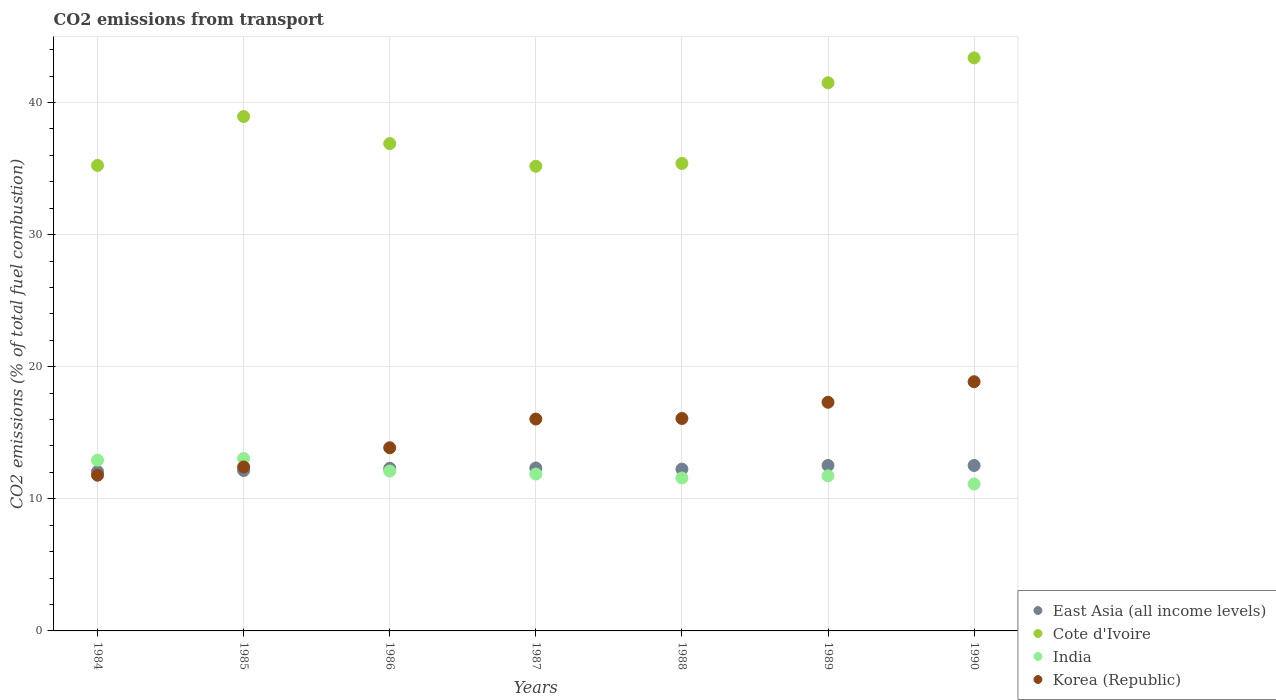How many different coloured dotlines are there?
Your response must be concise. 4. Is the number of dotlines equal to the number of legend labels?
Your answer should be very brief. Yes. What is the total CO2 emitted in Cote d'Ivoire in 1986?
Keep it short and to the point. 36.89. Across all years, what is the maximum total CO2 emitted in Korea (Republic)?
Keep it short and to the point. 18.87. Across all years, what is the minimum total CO2 emitted in India?
Your response must be concise. 11.12. In which year was the total CO2 emitted in East Asia (all income levels) maximum?
Your answer should be very brief. 1989. What is the total total CO2 emitted in India in the graph?
Ensure brevity in your answer.  84.4. What is the difference between the total CO2 emitted in Korea (Republic) in 1984 and that in 1985?
Give a very brief answer. -0.62. What is the difference between the total CO2 emitted in East Asia (all income levels) in 1984 and the total CO2 emitted in India in 1986?
Your answer should be compact. -0.03. What is the average total CO2 emitted in East Asia (all income levels) per year?
Your response must be concise. 12.31. In the year 1988, what is the difference between the total CO2 emitted in Cote d'Ivoire and total CO2 emitted in India?
Make the answer very short. 23.81. In how many years, is the total CO2 emitted in East Asia (all income levels) greater than 2?
Your response must be concise. 7. What is the ratio of the total CO2 emitted in Cote d'Ivoire in 1984 to that in 1985?
Provide a short and direct response. 0.9. Is the difference between the total CO2 emitted in Cote d'Ivoire in 1984 and 1985 greater than the difference between the total CO2 emitted in India in 1984 and 1985?
Your answer should be compact. No. What is the difference between the highest and the second highest total CO2 emitted in India?
Make the answer very short. 0.12. What is the difference between the highest and the lowest total CO2 emitted in Korea (Republic)?
Provide a succinct answer. 7.08. Is the sum of the total CO2 emitted in Cote d'Ivoire in 1984 and 1989 greater than the maximum total CO2 emitted in East Asia (all income levels) across all years?
Provide a short and direct response. Yes. Does the total CO2 emitted in Cote d'Ivoire monotonically increase over the years?
Keep it short and to the point. No. Is the total CO2 emitted in Cote d'Ivoire strictly greater than the total CO2 emitted in Korea (Republic) over the years?
Make the answer very short. Yes. Is the total CO2 emitted in Cote d'Ivoire strictly less than the total CO2 emitted in India over the years?
Your answer should be compact. No. How many dotlines are there?
Your answer should be very brief. 4. Are the values on the major ticks of Y-axis written in scientific E-notation?
Provide a succinct answer. No. Does the graph contain any zero values?
Your response must be concise. No. Does the graph contain grids?
Keep it short and to the point. Yes. Where does the legend appear in the graph?
Your answer should be very brief. Bottom right. How many legend labels are there?
Ensure brevity in your answer.  4. What is the title of the graph?
Provide a succinct answer. CO2 emissions from transport. What is the label or title of the Y-axis?
Offer a terse response. CO2 emissions (% of total fuel combustion). What is the CO2 emissions (% of total fuel combustion) of East Asia (all income levels) in 1984?
Offer a terse response. 12.07. What is the CO2 emissions (% of total fuel combustion) of Cote d'Ivoire in 1984?
Your answer should be very brief. 35.24. What is the CO2 emissions (% of total fuel combustion) of India in 1984?
Your answer should be compact. 12.93. What is the CO2 emissions (% of total fuel combustion) in Korea (Republic) in 1984?
Provide a short and direct response. 11.79. What is the CO2 emissions (% of total fuel combustion) in East Asia (all income levels) in 1985?
Your answer should be compact. 12.14. What is the CO2 emissions (% of total fuel combustion) in Cote d'Ivoire in 1985?
Ensure brevity in your answer.  38.94. What is the CO2 emissions (% of total fuel combustion) of India in 1985?
Offer a very short reply. 13.05. What is the CO2 emissions (% of total fuel combustion) of Korea (Republic) in 1985?
Make the answer very short. 12.41. What is the CO2 emissions (% of total fuel combustion) in East Asia (all income levels) in 1986?
Offer a very short reply. 12.31. What is the CO2 emissions (% of total fuel combustion) of Cote d'Ivoire in 1986?
Provide a succinct answer. 36.89. What is the CO2 emissions (% of total fuel combustion) in India in 1986?
Provide a short and direct response. 12.1. What is the CO2 emissions (% of total fuel combustion) in Korea (Republic) in 1986?
Give a very brief answer. 13.87. What is the CO2 emissions (% of total fuel combustion) of East Asia (all income levels) in 1987?
Provide a short and direct response. 12.34. What is the CO2 emissions (% of total fuel combustion) of Cote d'Ivoire in 1987?
Your answer should be very brief. 35.18. What is the CO2 emissions (% of total fuel combustion) in India in 1987?
Provide a succinct answer. 11.88. What is the CO2 emissions (% of total fuel combustion) in Korea (Republic) in 1987?
Your answer should be very brief. 16.04. What is the CO2 emissions (% of total fuel combustion) of East Asia (all income levels) in 1988?
Provide a short and direct response. 12.25. What is the CO2 emissions (% of total fuel combustion) in Cote d'Ivoire in 1988?
Offer a terse response. 35.39. What is the CO2 emissions (% of total fuel combustion) of India in 1988?
Make the answer very short. 11.58. What is the CO2 emissions (% of total fuel combustion) in Korea (Republic) in 1988?
Keep it short and to the point. 16.08. What is the CO2 emissions (% of total fuel combustion) of East Asia (all income levels) in 1989?
Offer a very short reply. 12.53. What is the CO2 emissions (% of total fuel combustion) of Cote d'Ivoire in 1989?
Keep it short and to the point. 41.5. What is the CO2 emissions (% of total fuel combustion) of India in 1989?
Your answer should be very brief. 11.74. What is the CO2 emissions (% of total fuel combustion) in Korea (Republic) in 1989?
Provide a short and direct response. 17.31. What is the CO2 emissions (% of total fuel combustion) in East Asia (all income levels) in 1990?
Your answer should be compact. 12.53. What is the CO2 emissions (% of total fuel combustion) in Cote d'Ivoire in 1990?
Your answer should be compact. 43.38. What is the CO2 emissions (% of total fuel combustion) of India in 1990?
Offer a terse response. 11.12. What is the CO2 emissions (% of total fuel combustion) in Korea (Republic) in 1990?
Your response must be concise. 18.87. Across all years, what is the maximum CO2 emissions (% of total fuel combustion) in East Asia (all income levels)?
Ensure brevity in your answer.  12.53. Across all years, what is the maximum CO2 emissions (% of total fuel combustion) in Cote d'Ivoire?
Offer a very short reply. 43.38. Across all years, what is the maximum CO2 emissions (% of total fuel combustion) in India?
Your response must be concise. 13.05. Across all years, what is the maximum CO2 emissions (% of total fuel combustion) in Korea (Republic)?
Offer a very short reply. 18.87. Across all years, what is the minimum CO2 emissions (% of total fuel combustion) in East Asia (all income levels)?
Your answer should be very brief. 12.07. Across all years, what is the minimum CO2 emissions (% of total fuel combustion) of Cote d'Ivoire?
Make the answer very short. 35.18. Across all years, what is the minimum CO2 emissions (% of total fuel combustion) in India?
Your response must be concise. 11.12. Across all years, what is the minimum CO2 emissions (% of total fuel combustion) in Korea (Republic)?
Your response must be concise. 11.79. What is the total CO2 emissions (% of total fuel combustion) in East Asia (all income levels) in the graph?
Your answer should be very brief. 86.16. What is the total CO2 emissions (% of total fuel combustion) in Cote d'Ivoire in the graph?
Provide a succinct answer. 266.53. What is the total CO2 emissions (% of total fuel combustion) in India in the graph?
Provide a short and direct response. 84.4. What is the total CO2 emissions (% of total fuel combustion) in Korea (Republic) in the graph?
Provide a succinct answer. 106.37. What is the difference between the CO2 emissions (% of total fuel combustion) in East Asia (all income levels) in 1984 and that in 1985?
Provide a succinct answer. -0.07. What is the difference between the CO2 emissions (% of total fuel combustion) of Cote d'Ivoire in 1984 and that in 1985?
Your answer should be very brief. -3.7. What is the difference between the CO2 emissions (% of total fuel combustion) of India in 1984 and that in 1985?
Your answer should be very brief. -0.12. What is the difference between the CO2 emissions (% of total fuel combustion) of Korea (Republic) in 1984 and that in 1985?
Your answer should be very brief. -0.62. What is the difference between the CO2 emissions (% of total fuel combustion) of East Asia (all income levels) in 1984 and that in 1986?
Your answer should be very brief. -0.24. What is the difference between the CO2 emissions (% of total fuel combustion) of Cote d'Ivoire in 1984 and that in 1986?
Your answer should be compact. -1.65. What is the difference between the CO2 emissions (% of total fuel combustion) of India in 1984 and that in 1986?
Ensure brevity in your answer.  0.83. What is the difference between the CO2 emissions (% of total fuel combustion) in Korea (Republic) in 1984 and that in 1986?
Offer a terse response. -2.08. What is the difference between the CO2 emissions (% of total fuel combustion) of East Asia (all income levels) in 1984 and that in 1987?
Give a very brief answer. -0.27. What is the difference between the CO2 emissions (% of total fuel combustion) of Cote d'Ivoire in 1984 and that in 1987?
Give a very brief answer. 0.06. What is the difference between the CO2 emissions (% of total fuel combustion) of India in 1984 and that in 1987?
Keep it short and to the point. 1.05. What is the difference between the CO2 emissions (% of total fuel combustion) of Korea (Republic) in 1984 and that in 1987?
Make the answer very short. -4.25. What is the difference between the CO2 emissions (% of total fuel combustion) of East Asia (all income levels) in 1984 and that in 1988?
Provide a succinct answer. -0.18. What is the difference between the CO2 emissions (% of total fuel combustion) in Cote d'Ivoire in 1984 and that in 1988?
Offer a terse response. -0.15. What is the difference between the CO2 emissions (% of total fuel combustion) in India in 1984 and that in 1988?
Provide a short and direct response. 1.35. What is the difference between the CO2 emissions (% of total fuel combustion) of Korea (Republic) in 1984 and that in 1988?
Offer a terse response. -4.29. What is the difference between the CO2 emissions (% of total fuel combustion) of East Asia (all income levels) in 1984 and that in 1989?
Give a very brief answer. -0.46. What is the difference between the CO2 emissions (% of total fuel combustion) in Cote d'Ivoire in 1984 and that in 1989?
Give a very brief answer. -6.26. What is the difference between the CO2 emissions (% of total fuel combustion) of India in 1984 and that in 1989?
Your answer should be compact. 1.19. What is the difference between the CO2 emissions (% of total fuel combustion) in Korea (Republic) in 1984 and that in 1989?
Provide a succinct answer. -5.52. What is the difference between the CO2 emissions (% of total fuel combustion) in East Asia (all income levels) in 1984 and that in 1990?
Offer a terse response. -0.46. What is the difference between the CO2 emissions (% of total fuel combustion) of Cote d'Ivoire in 1984 and that in 1990?
Ensure brevity in your answer.  -8.14. What is the difference between the CO2 emissions (% of total fuel combustion) in India in 1984 and that in 1990?
Your answer should be compact. 1.81. What is the difference between the CO2 emissions (% of total fuel combustion) in Korea (Republic) in 1984 and that in 1990?
Your answer should be compact. -7.08. What is the difference between the CO2 emissions (% of total fuel combustion) in East Asia (all income levels) in 1985 and that in 1986?
Offer a terse response. -0.17. What is the difference between the CO2 emissions (% of total fuel combustion) of Cote d'Ivoire in 1985 and that in 1986?
Provide a short and direct response. 2.05. What is the difference between the CO2 emissions (% of total fuel combustion) in India in 1985 and that in 1986?
Provide a succinct answer. 0.95. What is the difference between the CO2 emissions (% of total fuel combustion) of Korea (Republic) in 1985 and that in 1986?
Your answer should be compact. -1.46. What is the difference between the CO2 emissions (% of total fuel combustion) of East Asia (all income levels) in 1985 and that in 1987?
Your answer should be compact. -0.19. What is the difference between the CO2 emissions (% of total fuel combustion) of Cote d'Ivoire in 1985 and that in 1987?
Make the answer very short. 3.76. What is the difference between the CO2 emissions (% of total fuel combustion) in India in 1985 and that in 1987?
Provide a succinct answer. 1.18. What is the difference between the CO2 emissions (% of total fuel combustion) in Korea (Republic) in 1985 and that in 1987?
Ensure brevity in your answer.  -3.63. What is the difference between the CO2 emissions (% of total fuel combustion) of East Asia (all income levels) in 1985 and that in 1988?
Your answer should be compact. -0.11. What is the difference between the CO2 emissions (% of total fuel combustion) of Cote d'Ivoire in 1985 and that in 1988?
Make the answer very short. 3.55. What is the difference between the CO2 emissions (% of total fuel combustion) of India in 1985 and that in 1988?
Keep it short and to the point. 1.48. What is the difference between the CO2 emissions (% of total fuel combustion) in Korea (Republic) in 1985 and that in 1988?
Keep it short and to the point. -3.67. What is the difference between the CO2 emissions (% of total fuel combustion) of East Asia (all income levels) in 1985 and that in 1989?
Provide a succinct answer. -0.38. What is the difference between the CO2 emissions (% of total fuel combustion) in Cote d'Ivoire in 1985 and that in 1989?
Keep it short and to the point. -2.55. What is the difference between the CO2 emissions (% of total fuel combustion) in India in 1985 and that in 1989?
Your answer should be compact. 1.31. What is the difference between the CO2 emissions (% of total fuel combustion) in East Asia (all income levels) in 1985 and that in 1990?
Ensure brevity in your answer.  -0.38. What is the difference between the CO2 emissions (% of total fuel combustion) of Cote d'Ivoire in 1985 and that in 1990?
Make the answer very short. -4.44. What is the difference between the CO2 emissions (% of total fuel combustion) of India in 1985 and that in 1990?
Give a very brief answer. 1.93. What is the difference between the CO2 emissions (% of total fuel combustion) in Korea (Republic) in 1985 and that in 1990?
Ensure brevity in your answer.  -6.46. What is the difference between the CO2 emissions (% of total fuel combustion) in East Asia (all income levels) in 1986 and that in 1987?
Provide a short and direct response. -0.02. What is the difference between the CO2 emissions (% of total fuel combustion) in Cote d'Ivoire in 1986 and that in 1987?
Provide a short and direct response. 1.71. What is the difference between the CO2 emissions (% of total fuel combustion) of India in 1986 and that in 1987?
Provide a succinct answer. 0.23. What is the difference between the CO2 emissions (% of total fuel combustion) of Korea (Republic) in 1986 and that in 1987?
Provide a succinct answer. -2.17. What is the difference between the CO2 emissions (% of total fuel combustion) of East Asia (all income levels) in 1986 and that in 1988?
Offer a very short reply. 0.06. What is the difference between the CO2 emissions (% of total fuel combustion) of Cote d'Ivoire in 1986 and that in 1988?
Offer a very short reply. 1.5. What is the difference between the CO2 emissions (% of total fuel combustion) of India in 1986 and that in 1988?
Offer a very short reply. 0.53. What is the difference between the CO2 emissions (% of total fuel combustion) in Korea (Republic) in 1986 and that in 1988?
Provide a short and direct response. -2.22. What is the difference between the CO2 emissions (% of total fuel combustion) of East Asia (all income levels) in 1986 and that in 1989?
Offer a very short reply. -0.21. What is the difference between the CO2 emissions (% of total fuel combustion) of Cote d'Ivoire in 1986 and that in 1989?
Offer a terse response. -4.6. What is the difference between the CO2 emissions (% of total fuel combustion) in India in 1986 and that in 1989?
Your response must be concise. 0.36. What is the difference between the CO2 emissions (% of total fuel combustion) in Korea (Republic) in 1986 and that in 1989?
Your response must be concise. -3.44. What is the difference between the CO2 emissions (% of total fuel combustion) of East Asia (all income levels) in 1986 and that in 1990?
Offer a very short reply. -0.21. What is the difference between the CO2 emissions (% of total fuel combustion) in Cote d'Ivoire in 1986 and that in 1990?
Keep it short and to the point. -6.49. What is the difference between the CO2 emissions (% of total fuel combustion) of India in 1986 and that in 1990?
Your answer should be very brief. 0.98. What is the difference between the CO2 emissions (% of total fuel combustion) of Korea (Republic) in 1986 and that in 1990?
Provide a succinct answer. -5. What is the difference between the CO2 emissions (% of total fuel combustion) in East Asia (all income levels) in 1987 and that in 1988?
Make the answer very short. 0.09. What is the difference between the CO2 emissions (% of total fuel combustion) in Cote d'Ivoire in 1987 and that in 1988?
Give a very brief answer. -0.21. What is the difference between the CO2 emissions (% of total fuel combustion) of India in 1987 and that in 1988?
Provide a succinct answer. 0.3. What is the difference between the CO2 emissions (% of total fuel combustion) of Korea (Republic) in 1987 and that in 1988?
Your response must be concise. -0.04. What is the difference between the CO2 emissions (% of total fuel combustion) in East Asia (all income levels) in 1987 and that in 1989?
Your answer should be compact. -0.19. What is the difference between the CO2 emissions (% of total fuel combustion) in Cote d'Ivoire in 1987 and that in 1989?
Keep it short and to the point. -6.32. What is the difference between the CO2 emissions (% of total fuel combustion) in India in 1987 and that in 1989?
Offer a terse response. 0.14. What is the difference between the CO2 emissions (% of total fuel combustion) in Korea (Republic) in 1987 and that in 1989?
Provide a succinct answer. -1.27. What is the difference between the CO2 emissions (% of total fuel combustion) of East Asia (all income levels) in 1987 and that in 1990?
Your answer should be compact. -0.19. What is the difference between the CO2 emissions (% of total fuel combustion) in Cote d'Ivoire in 1987 and that in 1990?
Provide a succinct answer. -8.2. What is the difference between the CO2 emissions (% of total fuel combustion) in India in 1987 and that in 1990?
Make the answer very short. 0.76. What is the difference between the CO2 emissions (% of total fuel combustion) in Korea (Republic) in 1987 and that in 1990?
Your answer should be compact. -2.83. What is the difference between the CO2 emissions (% of total fuel combustion) of East Asia (all income levels) in 1988 and that in 1989?
Your answer should be very brief. -0.28. What is the difference between the CO2 emissions (% of total fuel combustion) in Cote d'Ivoire in 1988 and that in 1989?
Offer a terse response. -6.11. What is the difference between the CO2 emissions (% of total fuel combustion) of India in 1988 and that in 1989?
Keep it short and to the point. -0.16. What is the difference between the CO2 emissions (% of total fuel combustion) of Korea (Republic) in 1988 and that in 1989?
Your answer should be compact. -1.23. What is the difference between the CO2 emissions (% of total fuel combustion) in East Asia (all income levels) in 1988 and that in 1990?
Your response must be concise. -0.28. What is the difference between the CO2 emissions (% of total fuel combustion) in Cote d'Ivoire in 1988 and that in 1990?
Make the answer very short. -7.99. What is the difference between the CO2 emissions (% of total fuel combustion) of India in 1988 and that in 1990?
Your answer should be compact. 0.46. What is the difference between the CO2 emissions (% of total fuel combustion) in Korea (Republic) in 1988 and that in 1990?
Provide a short and direct response. -2.78. What is the difference between the CO2 emissions (% of total fuel combustion) in East Asia (all income levels) in 1989 and that in 1990?
Offer a terse response. 0. What is the difference between the CO2 emissions (% of total fuel combustion) of Cote d'Ivoire in 1989 and that in 1990?
Ensure brevity in your answer.  -1.89. What is the difference between the CO2 emissions (% of total fuel combustion) in India in 1989 and that in 1990?
Provide a short and direct response. 0.62. What is the difference between the CO2 emissions (% of total fuel combustion) in Korea (Republic) in 1989 and that in 1990?
Provide a short and direct response. -1.56. What is the difference between the CO2 emissions (% of total fuel combustion) in East Asia (all income levels) in 1984 and the CO2 emissions (% of total fuel combustion) in Cote d'Ivoire in 1985?
Make the answer very short. -26.87. What is the difference between the CO2 emissions (% of total fuel combustion) in East Asia (all income levels) in 1984 and the CO2 emissions (% of total fuel combustion) in India in 1985?
Offer a terse response. -0.98. What is the difference between the CO2 emissions (% of total fuel combustion) in East Asia (all income levels) in 1984 and the CO2 emissions (% of total fuel combustion) in Korea (Republic) in 1985?
Ensure brevity in your answer.  -0.34. What is the difference between the CO2 emissions (% of total fuel combustion) in Cote d'Ivoire in 1984 and the CO2 emissions (% of total fuel combustion) in India in 1985?
Provide a succinct answer. 22.19. What is the difference between the CO2 emissions (% of total fuel combustion) in Cote d'Ivoire in 1984 and the CO2 emissions (% of total fuel combustion) in Korea (Republic) in 1985?
Give a very brief answer. 22.83. What is the difference between the CO2 emissions (% of total fuel combustion) in India in 1984 and the CO2 emissions (% of total fuel combustion) in Korea (Republic) in 1985?
Give a very brief answer. 0.52. What is the difference between the CO2 emissions (% of total fuel combustion) in East Asia (all income levels) in 1984 and the CO2 emissions (% of total fuel combustion) in Cote d'Ivoire in 1986?
Your response must be concise. -24.82. What is the difference between the CO2 emissions (% of total fuel combustion) of East Asia (all income levels) in 1984 and the CO2 emissions (% of total fuel combustion) of India in 1986?
Keep it short and to the point. -0.03. What is the difference between the CO2 emissions (% of total fuel combustion) of East Asia (all income levels) in 1984 and the CO2 emissions (% of total fuel combustion) of Korea (Republic) in 1986?
Give a very brief answer. -1.8. What is the difference between the CO2 emissions (% of total fuel combustion) of Cote d'Ivoire in 1984 and the CO2 emissions (% of total fuel combustion) of India in 1986?
Your answer should be very brief. 23.14. What is the difference between the CO2 emissions (% of total fuel combustion) in Cote d'Ivoire in 1984 and the CO2 emissions (% of total fuel combustion) in Korea (Republic) in 1986?
Offer a very short reply. 21.37. What is the difference between the CO2 emissions (% of total fuel combustion) in India in 1984 and the CO2 emissions (% of total fuel combustion) in Korea (Republic) in 1986?
Keep it short and to the point. -0.94. What is the difference between the CO2 emissions (% of total fuel combustion) in East Asia (all income levels) in 1984 and the CO2 emissions (% of total fuel combustion) in Cote d'Ivoire in 1987?
Offer a very short reply. -23.11. What is the difference between the CO2 emissions (% of total fuel combustion) of East Asia (all income levels) in 1984 and the CO2 emissions (% of total fuel combustion) of India in 1987?
Offer a terse response. 0.19. What is the difference between the CO2 emissions (% of total fuel combustion) in East Asia (all income levels) in 1984 and the CO2 emissions (% of total fuel combustion) in Korea (Republic) in 1987?
Your answer should be compact. -3.97. What is the difference between the CO2 emissions (% of total fuel combustion) in Cote d'Ivoire in 1984 and the CO2 emissions (% of total fuel combustion) in India in 1987?
Your answer should be very brief. 23.36. What is the difference between the CO2 emissions (% of total fuel combustion) in India in 1984 and the CO2 emissions (% of total fuel combustion) in Korea (Republic) in 1987?
Ensure brevity in your answer.  -3.11. What is the difference between the CO2 emissions (% of total fuel combustion) of East Asia (all income levels) in 1984 and the CO2 emissions (% of total fuel combustion) of Cote d'Ivoire in 1988?
Offer a very short reply. -23.32. What is the difference between the CO2 emissions (% of total fuel combustion) of East Asia (all income levels) in 1984 and the CO2 emissions (% of total fuel combustion) of India in 1988?
Your answer should be very brief. 0.49. What is the difference between the CO2 emissions (% of total fuel combustion) in East Asia (all income levels) in 1984 and the CO2 emissions (% of total fuel combustion) in Korea (Republic) in 1988?
Ensure brevity in your answer.  -4.01. What is the difference between the CO2 emissions (% of total fuel combustion) in Cote d'Ivoire in 1984 and the CO2 emissions (% of total fuel combustion) in India in 1988?
Your response must be concise. 23.66. What is the difference between the CO2 emissions (% of total fuel combustion) in Cote d'Ivoire in 1984 and the CO2 emissions (% of total fuel combustion) in Korea (Republic) in 1988?
Offer a terse response. 19.16. What is the difference between the CO2 emissions (% of total fuel combustion) in India in 1984 and the CO2 emissions (% of total fuel combustion) in Korea (Republic) in 1988?
Your response must be concise. -3.15. What is the difference between the CO2 emissions (% of total fuel combustion) in East Asia (all income levels) in 1984 and the CO2 emissions (% of total fuel combustion) in Cote d'Ivoire in 1989?
Your response must be concise. -29.43. What is the difference between the CO2 emissions (% of total fuel combustion) of East Asia (all income levels) in 1984 and the CO2 emissions (% of total fuel combustion) of India in 1989?
Keep it short and to the point. 0.33. What is the difference between the CO2 emissions (% of total fuel combustion) of East Asia (all income levels) in 1984 and the CO2 emissions (% of total fuel combustion) of Korea (Republic) in 1989?
Offer a very short reply. -5.24. What is the difference between the CO2 emissions (% of total fuel combustion) in Cote d'Ivoire in 1984 and the CO2 emissions (% of total fuel combustion) in India in 1989?
Your answer should be compact. 23.5. What is the difference between the CO2 emissions (% of total fuel combustion) of Cote d'Ivoire in 1984 and the CO2 emissions (% of total fuel combustion) of Korea (Republic) in 1989?
Keep it short and to the point. 17.93. What is the difference between the CO2 emissions (% of total fuel combustion) in India in 1984 and the CO2 emissions (% of total fuel combustion) in Korea (Republic) in 1989?
Offer a very short reply. -4.38. What is the difference between the CO2 emissions (% of total fuel combustion) of East Asia (all income levels) in 1984 and the CO2 emissions (% of total fuel combustion) of Cote d'Ivoire in 1990?
Give a very brief answer. -31.31. What is the difference between the CO2 emissions (% of total fuel combustion) of East Asia (all income levels) in 1984 and the CO2 emissions (% of total fuel combustion) of India in 1990?
Make the answer very short. 0.95. What is the difference between the CO2 emissions (% of total fuel combustion) in East Asia (all income levels) in 1984 and the CO2 emissions (% of total fuel combustion) in Korea (Republic) in 1990?
Your answer should be compact. -6.8. What is the difference between the CO2 emissions (% of total fuel combustion) of Cote d'Ivoire in 1984 and the CO2 emissions (% of total fuel combustion) of India in 1990?
Your answer should be very brief. 24.12. What is the difference between the CO2 emissions (% of total fuel combustion) in Cote d'Ivoire in 1984 and the CO2 emissions (% of total fuel combustion) in Korea (Republic) in 1990?
Make the answer very short. 16.37. What is the difference between the CO2 emissions (% of total fuel combustion) of India in 1984 and the CO2 emissions (% of total fuel combustion) of Korea (Republic) in 1990?
Provide a succinct answer. -5.94. What is the difference between the CO2 emissions (% of total fuel combustion) of East Asia (all income levels) in 1985 and the CO2 emissions (% of total fuel combustion) of Cote d'Ivoire in 1986?
Ensure brevity in your answer.  -24.75. What is the difference between the CO2 emissions (% of total fuel combustion) of East Asia (all income levels) in 1985 and the CO2 emissions (% of total fuel combustion) of India in 1986?
Keep it short and to the point. 0.04. What is the difference between the CO2 emissions (% of total fuel combustion) of East Asia (all income levels) in 1985 and the CO2 emissions (% of total fuel combustion) of Korea (Republic) in 1986?
Ensure brevity in your answer.  -1.72. What is the difference between the CO2 emissions (% of total fuel combustion) of Cote d'Ivoire in 1985 and the CO2 emissions (% of total fuel combustion) of India in 1986?
Make the answer very short. 26.84. What is the difference between the CO2 emissions (% of total fuel combustion) of Cote d'Ivoire in 1985 and the CO2 emissions (% of total fuel combustion) of Korea (Republic) in 1986?
Keep it short and to the point. 25.08. What is the difference between the CO2 emissions (% of total fuel combustion) of India in 1985 and the CO2 emissions (% of total fuel combustion) of Korea (Republic) in 1986?
Ensure brevity in your answer.  -0.81. What is the difference between the CO2 emissions (% of total fuel combustion) in East Asia (all income levels) in 1985 and the CO2 emissions (% of total fuel combustion) in Cote d'Ivoire in 1987?
Keep it short and to the point. -23.04. What is the difference between the CO2 emissions (% of total fuel combustion) in East Asia (all income levels) in 1985 and the CO2 emissions (% of total fuel combustion) in India in 1987?
Offer a terse response. 0.26. What is the difference between the CO2 emissions (% of total fuel combustion) of East Asia (all income levels) in 1985 and the CO2 emissions (% of total fuel combustion) of Korea (Republic) in 1987?
Make the answer very short. -3.9. What is the difference between the CO2 emissions (% of total fuel combustion) in Cote d'Ivoire in 1985 and the CO2 emissions (% of total fuel combustion) in India in 1987?
Your answer should be very brief. 27.07. What is the difference between the CO2 emissions (% of total fuel combustion) in Cote d'Ivoire in 1985 and the CO2 emissions (% of total fuel combustion) in Korea (Republic) in 1987?
Your answer should be compact. 22.9. What is the difference between the CO2 emissions (% of total fuel combustion) in India in 1985 and the CO2 emissions (% of total fuel combustion) in Korea (Republic) in 1987?
Ensure brevity in your answer.  -2.99. What is the difference between the CO2 emissions (% of total fuel combustion) of East Asia (all income levels) in 1985 and the CO2 emissions (% of total fuel combustion) of Cote d'Ivoire in 1988?
Offer a very short reply. -23.25. What is the difference between the CO2 emissions (% of total fuel combustion) in East Asia (all income levels) in 1985 and the CO2 emissions (% of total fuel combustion) in India in 1988?
Give a very brief answer. 0.57. What is the difference between the CO2 emissions (% of total fuel combustion) in East Asia (all income levels) in 1985 and the CO2 emissions (% of total fuel combustion) in Korea (Republic) in 1988?
Make the answer very short. -3.94. What is the difference between the CO2 emissions (% of total fuel combustion) in Cote d'Ivoire in 1985 and the CO2 emissions (% of total fuel combustion) in India in 1988?
Give a very brief answer. 27.37. What is the difference between the CO2 emissions (% of total fuel combustion) of Cote d'Ivoire in 1985 and the CO2 emissions (% of total fuel combustion) of Korea (Republic) in 1988?
Your response must be concise. 22.86. What is the difference between the CO2 emissions (% of total fuel combustion) in India in 1985 and the CO2 emissions (% of total fuel combustion) in Korea (Republic) in 1988?
Your response must be concise. -3.03. What is the difference between the CO2 emissions (% of total fuel combustion) in East Asia (all income levels) in 1985 and the CO2 emissions (% of total fuel combustion) in Cote d'Ivoire in 1989?
Your answer should be compact. -29.35. What is the difference between the CO2 emissions (% of total fuel combustion) of East Asia (all income levels) in 1985 and the CO2 emissions (% of total fuel combustion) of India in 1989?
Provide a short and direct response. 0.4. What is the difference between the CO2 emissions (% of total fuel combustion) of East Asia (all income levels) in 1985 and the CO2 emissions (% of total fuel combustion) of Korea (Republic) in 1989?
Ensure brevity in your answer.  -5.17. What is the difference between the CO2 emissions (% of total fuel combustion) in Cote d'Ivoire in 1985 and the CO2 emissions (% of total fuel combustion) in India in 1989?
Your answer should be very brief. 27.2. What is the difference between the CO2 emissions (% of total fuel combustion) of Cote d'Ivoire in 1985 and the CO2 emissions (% of total fuel combustion) of Korea (Republic) in 1989?
Your answer should be very brief. 21.63. What is the difference between the CO2 emissions (% of total fuel combustion) of India in 1985 and the CO2 emissions (% of total fuel combustion) of Korea (Republic) in 1989?
Make the answer very short. -4.26. What is the difference between the CO2 emissions (% of total fuel combustion) of East Asia (all income levels) in 1985 and the CO2 emissions (% of total fuel combustion) of Cote d'Ivoire in 1990?
Offer a terse response. -31.24. What is the difference between the CO2 emissions (% of total fuel combustion) in East Asia (all income levels) in 1985 and the CO2 emissions (% of total fuel combustion) in India in 1990?
Give a very brief answer. 1.02. What is the difference between the CO2 emissions (% of total fuel combustion) in East Asia (all income levels) in 1985 and the CO2 emissions (% of total fuel combustion) in Korea (Republic) in 1990?
Your answer should be very brief. -6.72. What is the difference between the CO2 emissions (% of total fuel combustion) of Cote d'Ivoire in 1985 and the CO2 emissions (% of total fuel combustion) of India in 1990?
Provide a short and direct response. 27.83. What is the difference between the CO2 emissions (% of total fuel combustion) of Cote d'Ivoire in 1985 and the CO2 emissions (% of total fuel combustion) of Korea (Republic) in 1990?
Ensure brevity in your answer.  20.08. What is the difference between the CO2 emissions (% of total fuel combustion) in India in 1985 and the CO2 emissions (% of total fuel combustion) in Korea (Republic) in 1990?
Offer a very short reply. -5.81. What is the difference between the CO2 emissions (% of total fuel combustion) of East Asia (all income levels) in 1986 and the CO2 emissions (% of total fuel combustion) of Cote d'Ivoire in 1987?
Give a very brief answer. -22.87. What is the difference between the CO2 emissions (% of total fuel combustion) of East Asia (all income levels) in 1986 and the CO2 emissions (% of total fuel combustion) of India in 1987?
Provide a succinct answer. 0.44. What is the difference between the CO2 emissions (% of total fuel combustion) of East Asia (all income levels) in 1986 and the CO2 emissions (% of total fuel combustion) of Korea (Republic) in 1987?
Offer a terse response. -3.73. What is the difference between the CO2 emissions (% of total fuel combustion) in Cote d'Ivoire in 1986 and the CO2 emissions (% of total fuel combustion) in India in 1987?
Provide a short and direct response. 25.02. What is the difference between the CO2 emissions (% of total fuel combustion) of Cote d'Ivoire in 1986 and the CO2 emissions (% of total fuel combustion) of Korea (Republic) in 1987?
Offer a very short reply. 20.85. What is the difference between the CO2 emissions (% of total fuel combustion) of India in 1986 and the CO2 emissions (% of total fuel combustion) of Korea (Republic) in 1987?
Your answer should be very brief. -3.94. What is the difference between the CO2 emissions (% of total fuel combustion) in East Asia (all income levels) in 1986 and the CO2 emissions (% of total fuel combustion) in Cote d'Ivoire in 1988?
Keep it short and to the point. -23.08. What is the difference between the CO2 emissions (% of total fuel combustion) of East Asia (all income levels) in 1986 and the CO2 emissions (% of total fuel combustion) of India in 1988?
Make the answer very short. 0.74. What is the difference between the CO2 emissions (% of total fuel combustion) of East Asia (all income levels) in 1986 and the CO2 emissions (% of total fuel combustion) of Korea (Republic) in 1988?
Keep it short and to the point. -3.77. What is the difference between the CO2 emissions (% of total fuel combustion) in Cote d'Ivoire in 1986 and the CO2 emissions (% of total fuel combustion) in India in 1988?
Provide a short and direct response. 25.32. What is the difference between the CO2 emissions (% of total fuel combustion) of Cote d'Ivoire in 1986 and the CO2 emissions (% of total fuel combustion) of Korea (Republic) in 1988?
Your answer should be very brief. 20.81. What is the difference between the CO2 emissions (% of total fuel combustion) in India in 1986 and the CO2 emissions (% of total fuel combustion) in Korea (Republic) in 1988?
Provide a succinct answer. -3.98. What is the difference between the CO2 emissions (% of total fuel combustion) of East Asia (all income levels) in 1986 and the CO2 emissions (% of total fuel combustion) of Cote d'Ivoire in 1989?
Offer a terse response. -29.18. What is the difference between the CO2 emissions (% of total fuel combustion) of East Asia (all income levels) in 1986 and the CO2 emissions (% of total fuel combustion) of India in 1989?
Your answer should be compact. 0.57. What is the difference between the CO2 emissions (% of total fuel combustion) of East Asia (all income levels) in 1986 and the CO2 emissions (% of total fuel combustion) of Korea (Republic) in 1989?
Make the answer very short. -5. What is the difference between the CO2 emissions (% of total fuel combustion) in Cote d'Ivoire in 1986 and the CO2 emissions (% of total fuel combustion) in India in 1989?
Make the answer very short. 25.15. What is the difference between the CO2 emissions (% of total fuel combustion) of Cote d'Ivoire in 1986 and the CO2 emissions (% of total fuel combustion) of Korea (Republic) in 1989?
Keep it short and to the point. 19.58. What is the difference between the CO2 emissions (% of total fuel combustion) of India in 1986 and the CO2 emissions (% of total fuel combustion) of Korea (Republic) in 1989?
Your answer should be very brief. -5.21. What is the difference between the CO2 emissions (% of total fuel combustion) of East Asia (all income levels) in 1986 and the CO2 emissions (% of total fuel combustion) of Cote d'Ivoire in 1990?
Your answer should be very brief. -31.07. What is the difference between the CO2 emissions (% of total fuel combustion) in East Asia (all income levels) in 1986 and the CO2 emissions (% of total fuel combustion) in India in 1990?
Offer a very short reply. 1.19. What is the difference between the CO2 emissions (% of total fuel combustion) of East Asia (all income levels) in 1986 and the CO2 emissions (% of total fuel combustion) of Korea (Republic) in 1990?
Your response must be concise. -6.55. What is the difference between the CO2 emissions (% of total fuel combustion) of Cote d'Ivoire in 1986 and the CO2 emissions (% of total fuel combustion) of India in 1990?
Your response must be concise. 25.77. What is the difference between the CO2 emissions (% of total fuel combustion) in Cote d'Ivoire in 1986 and the CO2 emissions (% of total fuel combustion) in Korea (Republic) in 1990?
Give a very brief answer. 18.03. What is the difference between the CO2 emissions (% of total fuel combustion) in India in 1986 and the CO2 emissions (% of total fuel combustion) in Korea (Republic) in 1990?
Your response must be concise. -6.76. What is the difference between the CO2 emissions (% of total fuel combustion) in East Asia (all income levels) in 1987 and the CO2 emissions (% of total fuel combustion) in Cote d'Ivoire in 1988?
Make the answer very short. -23.05. What is the difference between the CO2 emissions (% of total fuel combustion) of East Asia (all income levels) in 1987 and the CO2 emissions (% of total fuel combustion) of India in 1988?
Offer a very short reply. 0.76. What is the difference between the CO2 emissions (% of total fuel combustion) of East Asia (all income levels) in 1987 and the CO2 emissions (% of total fuel combustion) of Korea (Republic) in 1988?
Ensure brevity in your answer.  -3.75. What is the difference between the CO2 emissions (% of total fuel combustion) of Cote d'Ivoire in 1987 and the CO2 emissions (% of total fuel combustion) of India in 1988?
Offer a terse response. 23.6. What is the difference between the CO2 emissions (% of total fuel combustion) in Cote d'Ivoire in 1987 and the CO2 emissions (% of total fuel combustion) in Korea (Republic) in 1988?
Your response must be concise. 19.1. What is the difference between the CO2 emissions (% of total fuel combustion) in India in 1987 and the CO2 emissions (% of total fuel combustion) in Korea (Republic) in 1988?
Offer a terse response. -4.2. What is the difference between the CO2 emissions (% of total fuel combustion) of East Asia (all income levels) in 1987 and the CO2 emissions (% of total fuel combustion) of Cote d'Ivoire in 1989?
Offer a terse response. -29.16. What is the difference between the CO2 emissions (% of total fuel combustion) in East Asia (all income levels) in 1987 and the CO2 emissions (% of total fuel combustion) in India in 1989?
Keep it short and to the point. 0.6. What is the difference between the CO2 emissions (% of total fuel combustion) of East Asia (all income levels) in 1987 and the CO2 emissions (% of total fuel combustion) of Korea (Republic) in 1989?
Make the answer very short. -4.98. What is the difference between the CO2 emissions (% of total fuel combustion) of Cote d'Ivoire in 1987 and the CO2 emissions (% of total fuel combustion) of India in 1989?
Offer a very short reply. 23.44. What is the difference between the CO2 emissions (% of total fuel combustion) in Cote d'Ivoire in 1987 and the CO2 emissions (% of total fuel combustion) in Korea (Republic) in 1989?
Offer a terse response. 17.87. What is the difference between the CO2 emissions (% of total fuel combustion) in India in 1987 and the CO2 emissions (% of total fuel combustion) in Korea (Republic) in 1989?
Ensure brevity in your answer.  -5.43. What is the difference between the CO2 emissions (% of total fuel combustion) of East Asia (all income levels) in 1987 and the CO2 emissions (% of total fuel combustion) of Cote d'Ivoire in 1990?
Provide a short and direct response. -31.05. What is the difference between the CO2 emissions (% of total fuel combustion) of East Asia (all income levels) in 1987 and the CO2 emissions (% of total fuel combustion) of India in 1990?
Provide a succinct answer. 1.22. What is the difference between the CO2 emissions (% of total fuel combustion) of East Asia (all income levels) in 1987 and the CO2 emissions (% of total fuel combustion) of Korea (Republic) in 1990?
Make the answer very short. -6.53. What is the difference between the CO2 emissions (% of total fuel combustion) in Cote d'Ivoire in 1987 and the CO2 emissions (% of total fuel combustion) in India in 1990?
Offer a very short reply. 24.06. What is the difference between the CO2 emissions (% of total fuel combustion) in Cote d'Ivoire in 1987 and the CO2 emissions (% of total fuel combustion) in Korea (Republic) in 1990?
Provide a short and direct response. 16.31. What is the difference between the CO2 emissions (% of total fuel combustion) in India in 1987 and the CO2 emissions (% of total fuel combustion) in Korea (Republic) in 1990?
Make the answer very short. -6.99. What is the difference between the CO2 emissions (% of total fuel combustion) in East Asia (all income levels) in 1988 and the CO2 emissions (% of total fuel combustion) in Cote d'Ivoire in 1989?
Provide a succinct answer. -29.25. What is the difference between the CO2 emissions (% of total fuel combustion) in East Asia (all income levels) in 1988 and the CO2 emissions (% of total fuel combustion) in India in 1989?
Keep it short and to the point. 0.51. What is the difference between the CO2 emissions (% of total fuel combustion) of East Asia (all income levels) in 1988 and the CO2 emissions (% of total fuel combustion) of Korea (Republic) in 1989?
Make the answer very short. -5.06. What is the difference between the CO2 emissions (% of total fuel combustion) in Cote d'Ivoire in 1988 and the CO2 emissions (% of total fuel combustion) in India in 1989?
Your answer should be very brief. 23.65. What is the difference between the CO2 emissions (% of total fuel combustion) of Cote d'Ivoire in 1988 and the CO2 emissions (% of total fuel combustion) of Korea (Republic) in 1989?
Your answer should be very brief. 18.08. What is the difference between the CO2 emissions (% of total fuel combustion) of India in 1988 and the CO2 emissions (% of total fuel combustion) of Korea (Republic) in 1989?
Give a very brief answer. -5.73. What is the difference between the CO2 emissions (% of total fuel combustion) of East Asia (all income levels) in 1988 and the CO2 emissions (% of total fuel combustion) of Cote d'Ivoire in 1990?
Provide a succinct answer. -31.13. What is the difference between the CO2 emissions (% of total fuel combustion) of East Asia (all income levels) in 1988 and the CO2 emissions (% of total fuel combustion) of India in 1990?
Make the answer very short. 1.13. What is the difference between the CO2 emissions (% of total fuel combustion) of East Asia (all income levels) in 1988 and the CO2 emissions (% of total fuel combustion) of Korea (Republic) in 1990?
Your answer should be compact. -6.62. What is the difference between the CO2 emissions (% of total fuel combustion) in Cote d'Ivoire in 1988 and the CO2 emissions (% of total fuel combustion) in India in 1990?
Your response must be concise. 24.27. What is the difference between the CO2 emissions (% of total fuel combustion) in Cote d'Ivoire in 1988 and the CO2 emissions (% of total fuel combustion) in Korea (Republic) in 1990?
Offer a terse response. 16.52. What is the difference between the CO2 emissions (% of total fuel combustion) of India in 1988 and the CO2 emissions (% of total fuel combustion) of Korea (Republic) in 1990?
Keep it short and to the point. -7.29. What is the difference between the CO2 emissions (% of total fuel combustion) in East Asia (all income levels) in 1989 and the CO2 emissions (% of total fuel combustion) in Cote d'Ivoire in 1990?
Offer a very short reply. -30.86. What is the difference between the CO2 emissions (% of total fuel combustion) in East Asia (all income levels) in 1989 and the CO2 emissions (% of total fuel combustion) in India in 1990?
Provide a short and direct response. 1.41. What is the difference between the CO2 emissions (% of total fuel combustion) of East Asia (all income levels) in 1989 and the CO2 emissions (% of total fuel combustion) of Korea (Republic) in 1990?
Your answer should be very brief. -6.34. What is the difference between the CO2 emissions (% of total fuel combustion) in Cote d'Ivoire in 1989 and the CO2 emissions (% of total fuel combustion) in India in 1990?
Keep it short and to the point. 30.38. What is the difference between the CO2 emissions (% of total fuel combustion) in Cote d'Ivoire in 1989 and the CO2 emissions (% of total fuel combustion) in Korea (Republic) in 1990?
Ensure brevity in your answer.  22.63. What is the difference between the CO2 emissions (% of total fuel combustion) in India in 1989 and the CO2 emissions (% of total fuel combustion) in Korea (Republic) in 1990?
Provide a short and direct response. -7.13. What is the average CO2 emissions (% of total fuel combustion) in East Asia (all income levels) per year?
Provide a succinct answer. 12.31. What is the average CO2 emissions (% of total fuel combustion) of Cote d'Ivoire per year?
Provide a short and direct response. 38.08. What is the average CO2 emissions (% of total fuel combustion) in India per year?
Give a very brief answer. 12.06. What is the average CO2 emissions (% of total fuel combustion) of Korea (Republic) per year?
Provide a short and direct response. 15.2. In the year 1984, what is the difference between the CO2 emissions (% of total fuel combustion) in East Asia (all income levels) and CO2 emissions (% of total fuel combustion) in Cote d'Ivoire?
Your response must be concise. -23.17. In the year 1984, what is the difference between the CO2 emissions (% of total fuel combustion) in East Asia (all income levels) and CO2 emissions (% of total fuel combustion) in India?
Ensure brevity in your answer.  -0.86. In the year 1984, what is the difference between the CO2 emissions (% of total fuel combustion) of East Asia (all income levels) and CO2 emissions (% of total fuel combustion) of Korea (Republic)?
Offer a terse response. 0.28. In the year 1984, what is the difference between the CO2 emissions (% of total fuel combustion) of Cote d'Ivoire and CO2 emissions (% of total fuel combustion) of India?
Give a very brief answer. 22.31. In the year 1984, what is the difference between the CO2 emissions (% of total fuel combustion) of Cote d'Ivoire and CO2 emissions (% of total fuel combustion) of Korea (Republic)?
Provide a succinct answer. 23.45. In the year 1984, what is the difference between the CO2 emissions (% of total fuel combustion) of India and CO2 emissions (% of total fuel combustion) of Korea (Republic)?
Ensure brevity in your answer.  1.14. In the year 1985, what is the difference between the CO2 emissions (% of total fuel combustion) of East Asia (all income levels) and CO2 emissions (% of total fuel combustion) of Cote d'Ivoire?
Offer a terse response. -26.8. In the year 1985, what is the difference between the CO2 emissions (% of total fuel combustion) of East Asia (all income levels) and CO2 emissions (% of total fuel combustion) of India?
Ensure brevity in your answer.  -0.91. In the year 1985, what is the difference between the CO2 emissions (% of total fuel combustion) of East Asia (all income levels) and CO2 emissions (% of total fuel combustion) of Korea (Republic)?
Your response must be concise. -0.27. In the year 1985, what is the difference between the CO2 emissions (% of total fuel combustion) in Cote d'Ivoire and CO2 emissions (% of total fuel combustion) in India?
Ensure brevity in your answer.  25.89. In the year 1985, what is the difference between the CO2 emissions (% of total fuel combustion) in Cote d'Ivoire and CO2 emissions (% of total fuel combustion) in Korea (Republic)?
Provide a succinct answer. 26.53. In the year 1985, what is the difference between the CO2 emissions (% of total fuel combustion) of India and CO2 emissions (% of total fuel combustion) of Korea (Republic)?
Make the answer very short. 0.64. In the year 1986, what is the difference between the CO2 emissions (% of total fuel combustion) in East Asia (all income levels) and CO2 emissions (% of total fuel combustion) in Cote d'Ivoire?
Make the answer very short. -24.58. In the year 1986, what is the difference between the CO2 emissions (% of total fuel combustion) in East Asia (all income levels) and CO2 emissions (% of total fuel combustion) in India?
Make the answer very short. 0.21. In the year 1986, what is the difference between the CO2 emissions (% of total fuel combustion) of East Asia (all income levels) and CO2 emissions (% of total fuel combustion) of Korea (Republic)?
Your answer should be compact. -1.55. In the year 1986, what is the difference between the CO2 emissions (% of total fuel combustion) in Cote d'Ivoire and CO2 emissions (% of total fuel combustion) in India?
Provide a succinct answer. 24.79. In the year 1986, what is the difference between the CO2 emissions (% of total fuel combustion) in Cote d'Ivoire and CO2 emissions (% of total fuel combustion) in Korea (Republic)?
Ensure brevity in your answer.  23.03. In the year 1986, what is the difference between the CO2 emissions (% of total fuel combustion) in India and CO2 emissions (% of total fuel combustion) in Korea (Republic)?
Make the answer very short. -1.76. In the year 1987, what is the difference between the CO2 emissions (% of total fuel combustion) in East Asia (all income levels) and CO2 emissions (% of total fuel combustion) in Cote d'Ivoire?
Offer a terse response. -22.84. In the year 1987, what is the difference between the CO2 emissions (% of total fuel combustion) of East Asia (all income levels) and CO2 emissions (% of total fuel combustion) of India?
Your response must be concise. 0.46. In the year 1987, what is the difference between the CO2 emissions (% of total fuel combustion) in East Asia (all income levels) and CO2 emissions (% of total fuel combustion) in Korea (Republic)?
Your answer should be compact. -3.71. In the year 1987, what is the difference between the CO2 emissions (% of total fuel combustion) of Cote d'Ivoire and CO2 emissions (% of total fuel combustion) of India?
Your answer should be very brief. 23.3. In the year 1987, what is the difference between the CO2 emissions (% of total fuel combustion) in Cote d'Ivoire and CO2 emissions (% of total fuel combustion) in Korea (Republic)?
Provide a short and direct response. 19.14. In the year 1987, what is the difference between the CO2 emissions (% of total fuel combustion) in India and CO2 emissions (% of total fuel combustion) in Korea (Republic)?
Your response must be concise. -4.16. In the year 1988, what is the difference between the CO2 emissions (% of total fuel combustion) of East Asia (all income levels) and CO2 emissions (% of total fuel combustion) of Cote d'Ivoire?
Give a very brief answer. -23.14. In the year 1988, what is the difference between the CO2 emissions (% of total fuel combustion) in East Asia (all income levels) and CO2 emissions (% of total fuel combustion) in India?
Ensure brevity in your answer.  0.67. In the year 1988, what is the difference between the CO2 emissions (% of total fuel combustion) of East Asia (all income levels) and CO2 emissions (% of total fuel combustion) of Korea (Republic)?
Offer a very short reply. -3.83. In the year 1988, what is the difference between the CO2 emissions (% of total fuel combustion) in Cote d'Ivoire and CO2 emissions (% of total fuel combustion) in India?
Offer a terse response. 23.81. In the year 1988, what is the difference between the CO2 emissions (% of total fuel combustion) of Cote d'Ivoire and CO2 emissions (% of total fuel combustion) of Korea (Republic)?
Keep it short and to the point. 19.31. In the year 1988, what is the difference between the CO2 emissions (% of total fuel combustion) of India and CO2 emissions (% of total fuel combustion) of Korea (Republic)?
Your response must be concise. -4.51. In the year 1989, what is the difference between the CO2 emissions (% of total fuel combustion) of East Asia (all income levels) and CO2 emissions (% of total fuel combustion) of Cote d'Ivoire?
Provide a short and direct response. -28.97. In the year 1989, what is the difference between the CO2 emissions (% of total fuel combustion) of East Asia (all income levels) and CO2 emissions (% of total fuel combustion) of India?
Provide a short and direct response. 0.78. In the year 1989, what is the difference between the CO2 emissions (% of total fuel combustion) of East Asia (all income levels) and CO2 emissions (% of total fuel combustion) of Korea (Republic)?
Your response must be concise. -4.79. In the year 1989, what is the difference between the CO2 emissions (% of total fuel combustion) in Cote d'Ivoire and CO2 emissions (% of total fuel combustion) in India?
Your answer should be compact. 29.76. In the year 1989, what is the difference between the CO2 emissions (% of total fuel combustion) of Cote d'Ivoire and CO2 emissions (% of total fuel combustion) of Korea (Republic)?
Keep it short and to the point. 24.19. In the year 1989, what is the difference between the CO2 emissions (% of total fuel combustion) of India and CO2 emissions (% of total fuel combustion) of Korea (Republic)?
Provide a succinct answer. -5.57. In the year 1990, what is the difference between the CO2 emissions (% of total fuel combustion) in East Asia (all income levels) and CO2 emissions (% of total fuel combustion) in Cote d'Ivoire?
Your response must be concise. -30.86. In the year 1990, what is the difference between the CO2 emissions (% of total fuel combustion) in East Asia (all income levels) and CO2 emissions (% of total fuel combustion) in India?
Keep it short and to the point. 1.41. In the year 1990, what is the difference between the CO2 emissions (% of total fuel combustion) of East Asia (all income levels) and CO2 emissions (% of total fuel combustion) of Korea (Republic)?
Offer a very short reply. -6.34. In the year 1990, what is the difference between the CO2 emissions (% of total fuel combustion) of Cote d'Ivoire and CO2 emissions (% of total fuel combustion) of India?
Your answer should be very brief. 32.26. In the year 1990, what is the difference between the CO2 emissions (% of total fuel combustion) in Cote d'Ivoire and CO2 emissions (% of total fuel combustion) in Korea (Republic)?
Keep it short and to the point. 24.52. In the year 1990, what is the difference between the CO2 emissions (% of total fuel combustion) in India and CO2 emissions (% of total fuel combustion) in Korea (Republic)?
Make the answer very short. -7.75. What is the ratio of the CO2 emissions (% of total fuel combustion) in East Asia (all income levels) in 1984 to that in 1985?
Offer a terse response. 0.99. What is the ratio of the CO2 emissions (% of total fuel combustion) of Cote d'Ivoire in 1984 to that in 1985?
Offer a terse response. 0.9. What is the ratio of the CO2 emissions (% of total fuel combustion) of Korea (Republic) in 1984 to that in 1985?
Offer a very short reply. 0.95. What is the ratio of the CO2 emissions (% of total fuel combustion) of East Asia (all income levels) in 1984 to that in 1986?
Offer a very short reply. 0.98. What is the ratio of the CO2 emissions (% of total fuel combustion) of Cote d'Ivoire in 1984 to that in 1986?
Offer a terse response. 0.96. What is the ratio of the CO2 emissions (% of total fuel combustion) of India in 1984 to that in 1986?
Offer a very short reply. 1.07. What is the ratio of the CO2 emissions (% of total fuel combustion) in Korea (Republic) in 1984 to that in 1986?
Ensure brevity in your answer.  0.85. What is the ratio of the CO2 emissions (% of total fuel combustion) of East Asia (all income levels) in 1984 to that in 1987?
Provide a succinct answer. 0.98. What is the ratio of the CO2 emissions (% of total fuel combustion) of Cote d'Ivoire in 1984 to that in 1987?
Keep it short and to the point. 1. What is the ratio of the CO2 emissions (% of total fuel combustion) in India in 1984 to that in 1987?
Give a very brief answer. 1.09. What is the ratio of the CO2 emissions (% of total fuel combustion) in Korea (Republic) in 1984 to that in 1987?
Ensure brevity in your answer.  0.73. What is the ratio of the CO2 emissions (% of total fuel combustion) of Cote d'Ivoire in 1984 to that in 1988?
Offer a terse response. 1. What is the ratio of the CO2 emissions (% of total fuel combustion) in India in 1984 to that in 1988?
Provide a succinct answer. 1.12. What is the ratio of the CO2 emissions (% of total fuel combustion) of Korea (Republic) in 1984 to that in 1988?
Offer a terse response. 0.73. What is the ratio of the CO2 emissions (% of total fuel combustion) in East Asia (all income levels) in 1984 to that in 1989?
Your answer should be compact. 0.96. What is the ratio of the CO2 emissions (% of total fuel combustion) in Cote d'Ivoire in 1984 to that in 1989?
Provide a short and direct response. 0.85. What is the ratio of the CO2 emissions (% of total fuel combustion) of India in 1984 to that in 1989?
Ensure brevity in your answer.  1.1. What is the ratio of the CO2 emissions (% of total fuel combustion) in Korea (Republic) in 1984 to that in 1989?
Make the answer very short. 0.68. What is the ratio of the CO2 emissions (% of total fuel combustion) of East Asia (all income levels) in 1984 to that in 1990?
Keep it short and to the point. 0.96. What is the ratio of the CO2 emissions (% of total fuel combustion) of Cote d'Ivoire in 1984 to that in 1990?
Provide a short and direct response. 0.81. What is the ratio of the CO2 emissions (% of total fuel combustion) in India in 1984 to that in 1990?
Provide a succinct answer. 1.16. What is the ratio of the CO2 emissions (% of total fuel combustion) of Korea (Republic) in 1984 to that in 1990?
Your answer should be very brief. 0.62. What is the ratio of the CO2 emissions (% of total fuel combustion) in East Asia (all income levels) in 1985 to that in 1986?
Offer a very short reply. 0.99. What is the ratio of the CO2 emissions (% of total fuel combustion) in Cote d'Ivoire in 1985 to that in 1986?
Give a very brief answer. 1.06. What is the ratio of the CO2 emissions (% of total fuel combustion) of India in 1985 to that in 1986?
Provide a short and direct response. 1.08. What is the ratio of the CO2 emissions (% of total fuel combustion) in Korea (Republic) in 1985 to that in 1986?
Ensure brevity in your answer.  0.9. What is the ratio of the CO2 emissions (% of total fuel combustion) of East Asia (all income levels) in 1985 to that in 1987?
Offer a very short reply. 0.98. What is the ratio of the CO2 emissions (% of total fuel combustion) of Cote d'Ivoire in 1985 to that in 1987?
Keep it short and to the point. 1.11. What is the ratio of the CO2 emissions (% of total fuel combustion) in India in 1985 to that in 1987?
Keep it short and to the point. 1.1. What is the ratio of the CO2 emissions (% of total fuel combustion) of Korea (Republic) in 1985 to that in 1987?
Offer a very short reply. 0.77. What is the ratio of the CO2 emissions (% of total fuel combustion) in Cote d'Ivoire in 1985 to that in 1988?
Your response must be concise. 1.1. What is the ratio of the CO2 emissions (% of total fuel combustion) in India in 1985 to that in 1988?
Offer a terse response. 1.13. What is the ratio of the CO2 emissions (% of total fuel combustion) of Korea (Republic) in 1985 to that in 1988?
Provide a short and direct response. 0.77. What is the ratio of the CO2 emissions (% of total fuel combustion) in East Asia (all income levels) in 1985 to that in 1989?
Offer a very short reply. 0.97. What is the ratio of the CO2 emissions (% of total fuel combustion) of Cote d'Ivoire in 1985 to that in 1989?
Provide a succinct answer. 0.94. What is the ratio of the CO2 emissions (% of total fuel combustion) in India in 1985 to that in 1989?
Your response must be concise. 1.11. What is the ratio of the CO2 emissions (% of total fuel combustion) of Korea (Republic) in 1985 to that in 1989?
Your answer should be compact. 0.72. What is the ratio of the CO2 emissions (% of total fuel combustion) of East Asia (all income levels) in 1985 to that in 1990?
Ensure brevity in your answer.  0.97. What is the ratio of the CO2 emissions (% of total fuel combustion) of Cote d'Ivoire in 1985 to that in 1990?
Provide a succinct answer. 0.9. What is the ratio of the CO2 emissions (% of total fuel combustion) of India in 1985 to that in 1990?
Provide a succinct answer. 1.17. What is the ratio of the CO2 emissions (% of total fuel combustion) in Korea (Republic) in 1985 to that in 1990?
Offer a very short reply. 0.66. What is the ratio of the CO2 emissions (% of total fuel combustion) of Cote d'Ivoire in 1986 to that in 1987?
Provide a succinct answer. 1.05. What is the ratio of the CO2 emissions (% of total fuel combustion) of India in 1986 to that in 1987?
Provide a succinct answer. 1.02. What is the ratio of the CO2 emissions (% of total fuel combustion) of Korea (Republic) in 1986 to that in 1987?
Offer a very short reply. 0.86. What is the ratio of the CO2 emissions (% of total fuel combustion) in Cote d'Ivoire in 1986 to that in 1988?
Provide a succinct answer. 1.04. What is the ratio of the CO2 emissions (% of total fuel combustion) of India in 1986 to that in 1988?
Offer a terse response. 1.05. What is the ratio of the CO2 emissions (% of total fuel combustion) in Korea (Republic) in 1986 to that in 1988?
Give a very brief answer. 0.86. What is the ratio of the CO2 emissions (% of total fuel combustion) of East Asia (all income levels) in 1986 to that in 1989?
Keep it short and to the point. 0.98. What is the ratio of the CO2 emissions (% of total fuel combustion) in Cote d'Ivoire in 1986 to that in 1989?
Provide a succinct answer. 0.89. What is the ratio of the CO2 emissions (% of total fuel combustion) in India in 1986 to that in 1989?
Provide a short and direct response. 1.03. What is the ratio of the CO2 emissions (% of total fuel combustion) of Korea (Republic) in 1986 to that in 1989?
Your answer should be very brief. 0.8. What is the ratio of the CO2 emissions (% of total fuel combustion) of East Asia (all income levels) in 1986 to that in 1990?
Offer a very short reply. 0.98. What is the ratio of the CO2 emissions (% of total fuel combustion) in Cote d'Ivoire in 1986 to that in 1990?
Provide a short and direct response. 0.85. What is the ratio of the CO2 emissions (% of total fuel combustion) in India in 1986 to that in 1990?
Give a very brief answer. 1.09. What is the ratio of the CO2 emissions (% of total fuel combustion) of Korea (Republic) in 1986 to that in 1990?
Make the answer very short. 0.73. What is the ratio of the CO2 emissions (% of total fuel combustion) in East Asia (all income levels) in 1987 to that in 1988?
Offer a terse response. 1.01. What is the ratio of the CO2 emissions (% of total fuel combustion) of India in 1987 to that in 1988?
Offer a very short reply. 1.03. What is the ratio of the CO2 emissions (% of total fuel combustion) in Korea (Republic) in 1987 to that in 1988?
Offer a terse response. 1. What is the ratio of the CO2 emissions (% of total fuel combustion) in East Asia (all income levels) in 1987 to that in 1989?
Give a very brief answer. 0.98. What is the ratio of the CO2 emissions (% of total fuel combustion) of Cote d'Ivoire in 1987 to that in 1989?
Your answer should be very brief. 0.85. What is the ratio of the CO2 emissions (% of total fuel combustion) of India in 1987 to that in 1989?
Your response must be concise. 1.01. What is the ratio of the CO2 emissions (% of total fuel combustion) in Korea (Republic) in 1987 to that in 1989?
Make the answer very short. 0.93. What is the ratio of the CO2 emissions (% of total fuel combustion) in East Asia (all income levels) in 1987 to that in 1990?
Your answer should be compact. 0.98. What is the ratio of the CO2 emissions (% of total fuel combustion) in Cote d'Ivoire in 1987 to that in 1990?
Your response must be concise. 0.81. What is the ratio of the CO2 emissions (% of total fuel combustion) in India in 1987 to that in 1990?
Your answer should be compact. 1.07. What is the ratio of the CO2 emissions (% of total fuel combustion) of Korea (Republic) in 1987 to that in 1990?
Offer a terse response. 0.85. What is the ratio of the CO2 emissions (% of total fuel combustion) of East Asia (all income levels) in 1988 to that in 1989?
Provide a short and direct response. 0.98. What is the ratio of the CO2 emissions (% of total fuel combustion) of Cote d'Ivoire in 1988 to that in 1989?
Offer a very short reply. 0.85. What is the ratio of the CO2 emissions (% of total fuel combustion) of India in 1988 to that in 1989?
Ensure brevity in your answer.  0.99. What is the ratio of the CO2 emissions (% of total fuel combustion) of Korea (Republic) in 1988 to that in 1989?
Make the answer very short. 0.93. What is the ratio of the CO2 emissions (% of total fuel combustion) in Cote d'Ivoire in 1988 to that in 1990?
Your response must be concise. 0.82. What is the ratio of the CO2 emissions (% of total fuel combustion) of India in 1988 to that in 1990?
Offer a very short reply. 1.04. What is the ratio of the CO2 emissions (% of total fuel combustion) in Korea (Republic) in 1988 to that in 1990?
Provide a succinct answer. 0.85. What is the ratio of the CO2 emissions (% of total fuel combustion) in Cote d'Ivoire in 1989 to that in 1990?
Offer a very short reply. 0.96. What is the ratio of the CO2 emissions (% of total fuel combustion) of India in 1989 to that in 1990?
Ensure brevity in your answer.  1.06. What is the ratio of the CO2 emissions (% of total fuel combustion) of Korea (Republic) in 1989 to that in 1990?
Offer a very short reply. 0.92. What is the difference between the highest and the second highest CO2 emissions (% of total fuel combustion) of Cote d'Ivoire?
Offer a very short reply. 1.89. What is the difference between the highest and the second highest CO2 emissions (% of total fuel combustion) in India?
Provide a succinct answer. 0.12. What is the difference between the highest and the second highest CO2 emissions (% of total fuel combustion) of Korea (Republic)?
Keep it short and to the point. 1.56. What is the difference between the highest and the lowest CO2 emissions (% of total fuel combustion) in East Asia (all income levels)?
Your answer should be compact. 0.46. What is the difference between the highest and the lowest CO2 emissions (% of total fuel combustion) of Cote d'Ivoire?
Your response must be concise. 8.2. What is the difference between the highest and the lowest CO2 emissions (% of total fuel combustion) in India?
Offer a very short reply. 1.93. What is the difference between the highest and the lowest CO2 emissions (% of total fuel combustion) of Korea (Republic)?
Make the answer very short. 7.08. 